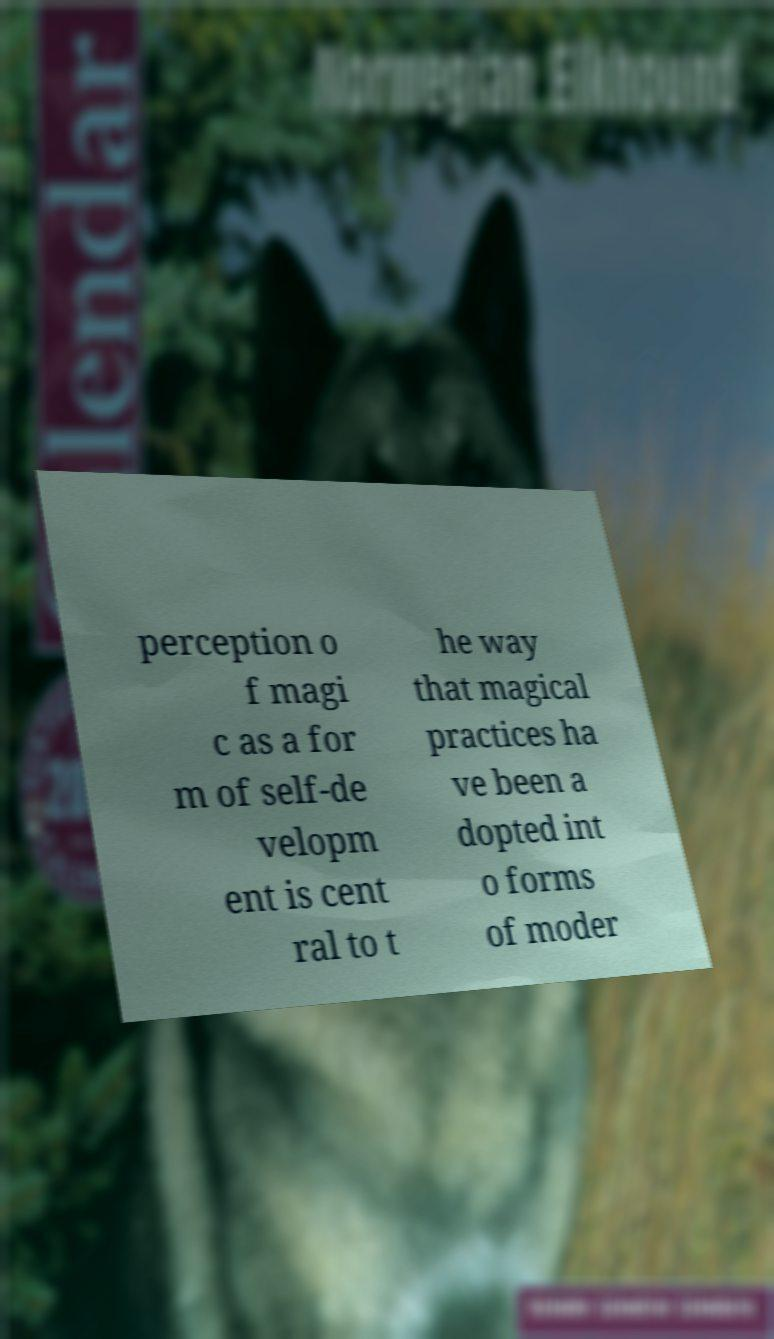I need the written content from this picture converted into text. Can you do that? perception o f magi c as a for m of self-de velopm ent is cent ral to t he way that magical practices ha ve been a dopted int o forms of moder 